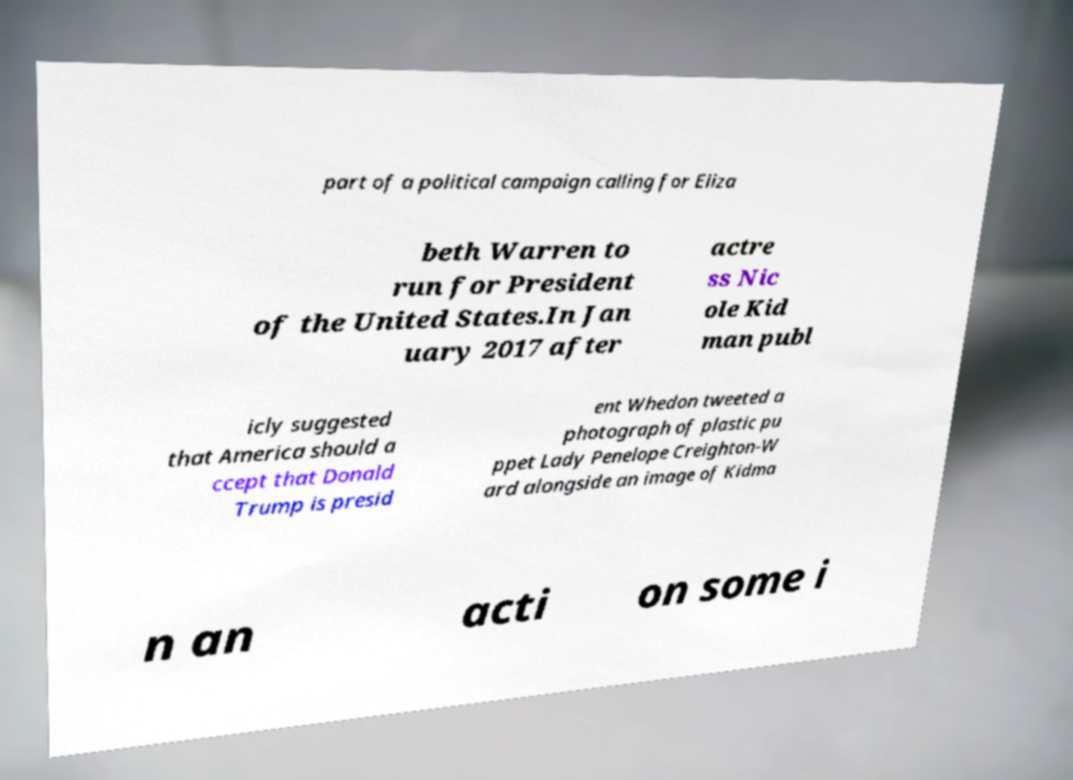Please identify and transcribe the text found in this image. part of a political campaign calling for Eliza beth Warren to run for President of the United States.In Jan uary 2017 after actre ss Nic ole Kid man publ icly suggested that America should a ccept that Donald Trump is presid ent Whedon tweeted a photograph of plastic pu ppet Lady Penelope Creighton-W ard alongside an image of Kidma n an acti on some i 